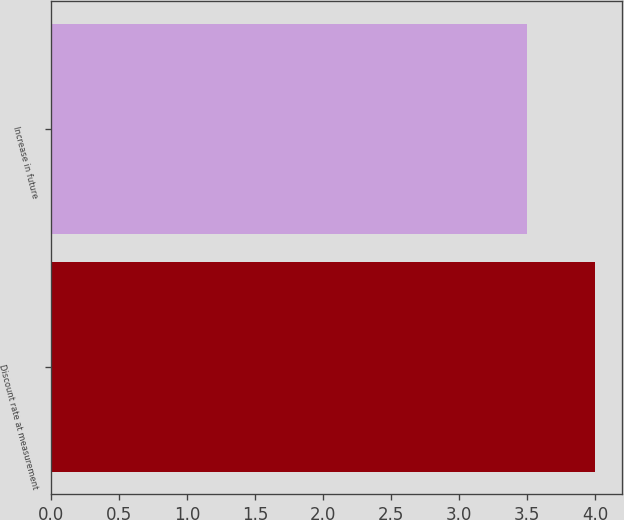Convert chart to OTSL. <chart><loc_0><loc_0><loc_500><loc_500><bar_chart><fcel>Discount rate at measurement<fcel>Increase in future<nl><fcel>4<fcel>3.5<nl></chart> 